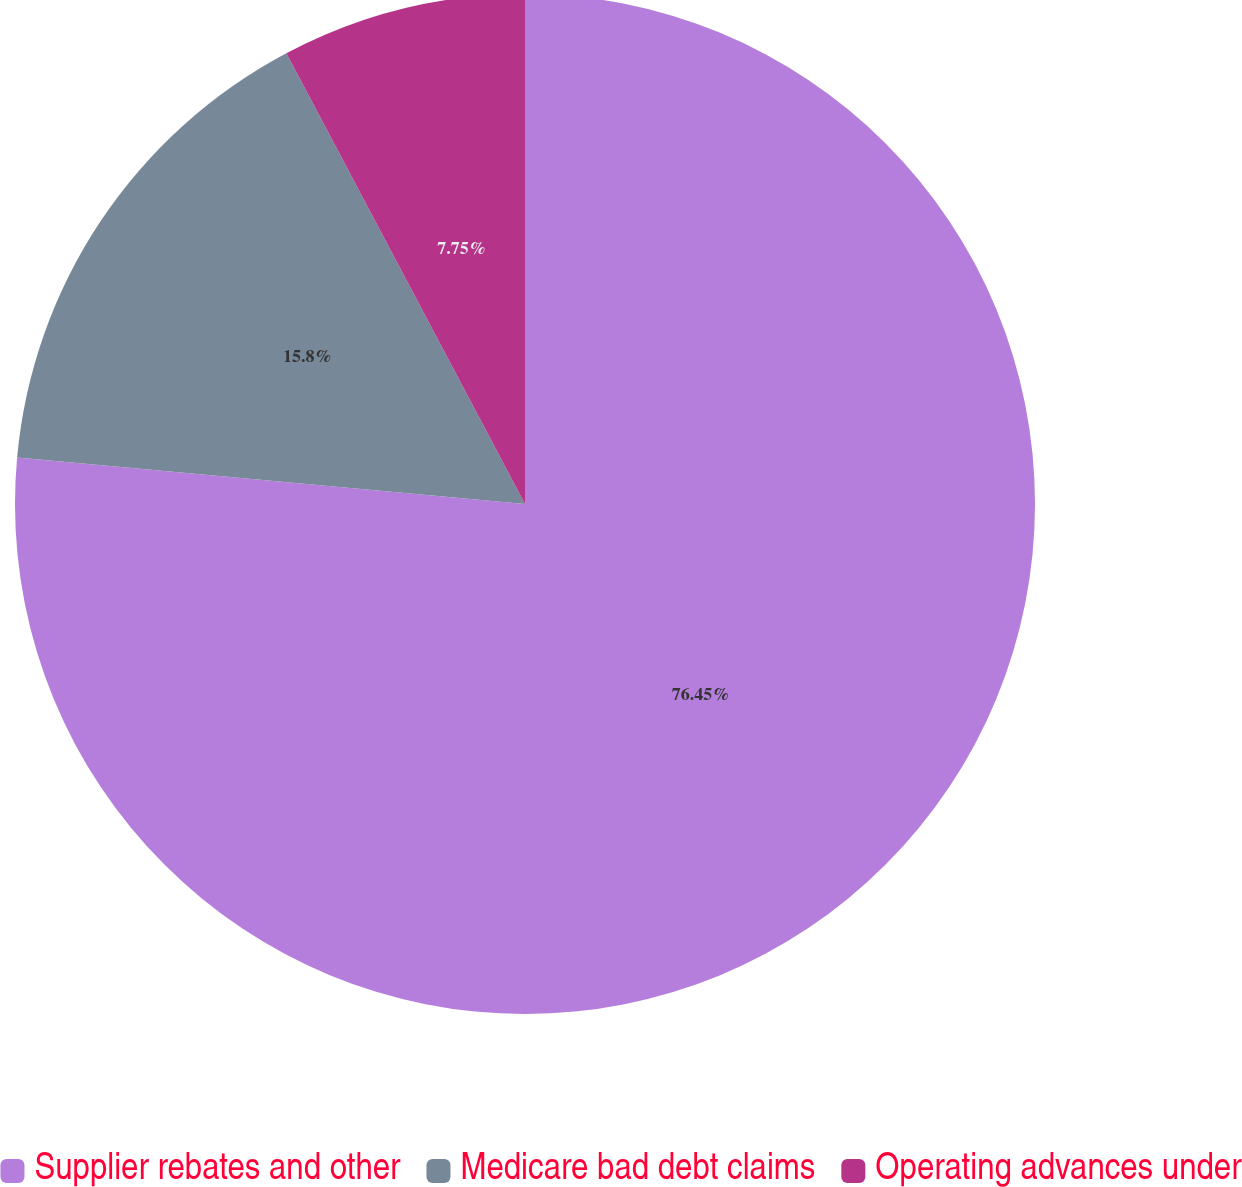Convert chart to OTSL. <chart><loc_0><loc_0><loc_500><loc_500><pie_chart><fcel>Supplier rebates and other<fcel>Medicare bad debt claims<fcel>Operating advances under<nl><fcel>76.45%<fcel>15.8%<fcel>7.75%<nl></chart> 